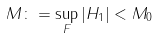Convert formula to latex. <formula><loc_0><loc_0><loc_500><loc_500>M \colon = \sup _ { F } | H _ { 1 } | < M _ { 0 }</formula> 